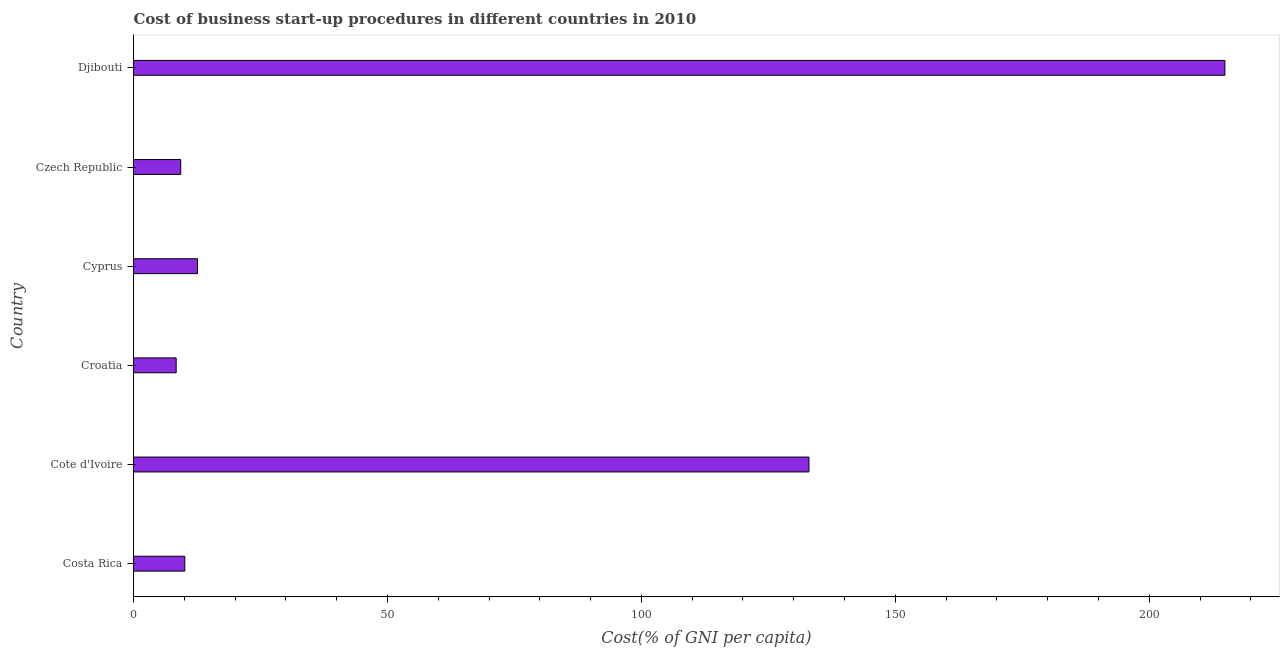Does the graph contain any zero values?
Give a very brief answer. No. What is the title of the graph?
Provide a succinct answer. Cost of business start-up procedures in different countries in 2010. What is the label or title of the X-axis?
Provide a short and direct response. Cost(% of GNI per capita). What is the cost of business startup procedures in Djibouti?
Keep it short and to the point. 214.9. Across all countries, what is the maximum cost of business startup procedures?
Offer a very short reply. 214.9. In which country was the cost of business startup procedures maximum?
Offer a very short reply. Djibouti. In which country was the cost of business startup procedures minimum?
Your answer should be very brief. Croatia. What is the sum of the cost of business startup procedures?
Offer a terse response. 388.3. What is the average cost of business startup procedures per country?
Provide a succinct answer. 64.72. What is the median cost of business startup procedures?
Your response must be concise. 11.35. What is the ratio of the cost of business startup procedures in Cote d'Ivoire to that in Croatia?
Ensure brevity in your answer.  15.83. Is the difference between the cost of business startup procedures in Costa Rica and Czech Republic greater than the difference between any two countries?
Your answer should be very brief. No. What is the difference between the highest and the second highest cost of business startup procedures?
Offer a terse response. 81.9. Is the sum of the cost of business startup procedures in Croatia and Czech Republic greater than the maximum cost of business startup procedures across all countries?
Ensure brevity in your answer.  No. What is the difference between the highest and the lowest cost of business startup procedures?
Provide a succinct answer. 206.5. In how many countries, is the cost of business startup procedures greater than the average cost of business startup procedures taken over all countries?
Make the answer very short. 2. What is the Cost(% of GNI per capita) of Costa Rica?
Make the answer very short. 10.1. What is the Cost(% of GNI per capita) of Cote d'Ivoire?
Offer a terse response. 133. What is the Cost(% of GNI per capita) in Cyprus?
Keep it short and to the point. 12.6. What is the Cost(% of GNI per capita) of Djibouti?
Offer a terse response. 214.9. What is the difference between the Cost(% of GNI per capita) in Costa Rica and Cote d'Ivoire?
Provide a succinct answer. -122.9. What is the difference between the Cost(% of GNI per capita) in Costa Rica and Czech Republic?
Your answer should be compact. 0.8. What is the difference between the Cost(% of GNI per capita) in Costa Rica and Djibouti?
Provide a succinct answer. -204.8. What is the difference between the Cost(% of GNI per capita) in Cote d'Ivoire and Croatia?
Give a very brief answer. 124.6. What is the difference between the Cost(% of GNI per capita) in Cote d'Ivoire and Cyprus?
Give a very brief answer. 120.4. What is the difference between the Cost(% of GNI per capita) in Cote d'Ivoire and Czech Republic?
Provide a short and direct response. 123.7. What is the difference between the Cost(% of GNI per capita) in Cote d'Ivoire and Djibouti?
Provide a short and direct response. -81.9. What is the difference between the Cost(% of GNI per capita) in Croatia and Djibouti?
Your answer should be very brief. -206.5. What is the difference between the Cost(% of GNI per capita) in Cyprus and Czech Republic?
Provide a succinct answer. 3.3. What is the difference between the Cost(% of GNI per capita) in Cyprus and Djibouti?
Provide a succinct answer. -202.3. What is the difference between the Cost(% of GNI per capita) in Czech Republic and Djibouti?
Ensure brevity in your answer.  -205.6. What is the ratio of the Cost(% of GNI per capita) in Costa Rica to that in Cote d'Ivoire?
Provide a short and direct response. 0.08. What is the ratio of the Cost(% of GNI per capita) in Costa Rica to that in Croatia?
Ensure brevity in your answer.  1.2. What is the ratio of the Cost(% of GNI per capita) in Costa Rica to that in Cyprus?
Your response must be concise. 0.8. What is the ratio of the Cost(% of GNI per capita) in Costa Rica to that in Czech Republic?
Your answer should be compact. 1.09. What is the ratio of the Cost(% of GNI per capita) in Costa Rica to that in Djibouti?
Offer a very short reply. 0.05. What is the ratio of the Cost(% of GNI per capita) in Cote d'Ivoire to that in Croatia?
Your answer should be compact. 15.83. What is the ratio of the Cost(% of GNI per capita) in Cote d'Ivoire to that in Cyprus?
Make the answer very short. 10.56. What is the ratio of the Cost(% of GNI per capita) in Cote d'Ivoire to that in Czech Republic?
Your answer should be compact. 14.3. What is the ratio of the Cost(% of GNI per capita) in Cote d'Ivoire to that in Djibouti?
Provide a succinct answer. 0.62. What is the ratio of the Cost(% of GNI per capita) in Croatia to that in Cyprus?
Offer a very short reply. 0.67. What is the ratio of the Cost(% of GNI per capita) in Croatia to that in Czech Republic?
Your response must be concise. 0.9. What is the ratio of the Cost(% of GNI per capita) in Croatia to that in Djibouti?
Make the answer very short. 0.04. What is the ratio of the Cost(% of GNI per capita) in Cyprus to that in Czech Republic?
Your answer should be compact. 1.35. What is the ratio of the Cost(% of GNI per capita) in Cyprus to that in Djibouti?
Keep it short and to the point. 0.06. What is the ratio of the Cost(% of GNI per capita) in Czech Republic to that in Djibouti?
Make the answer very short. 0.04. 